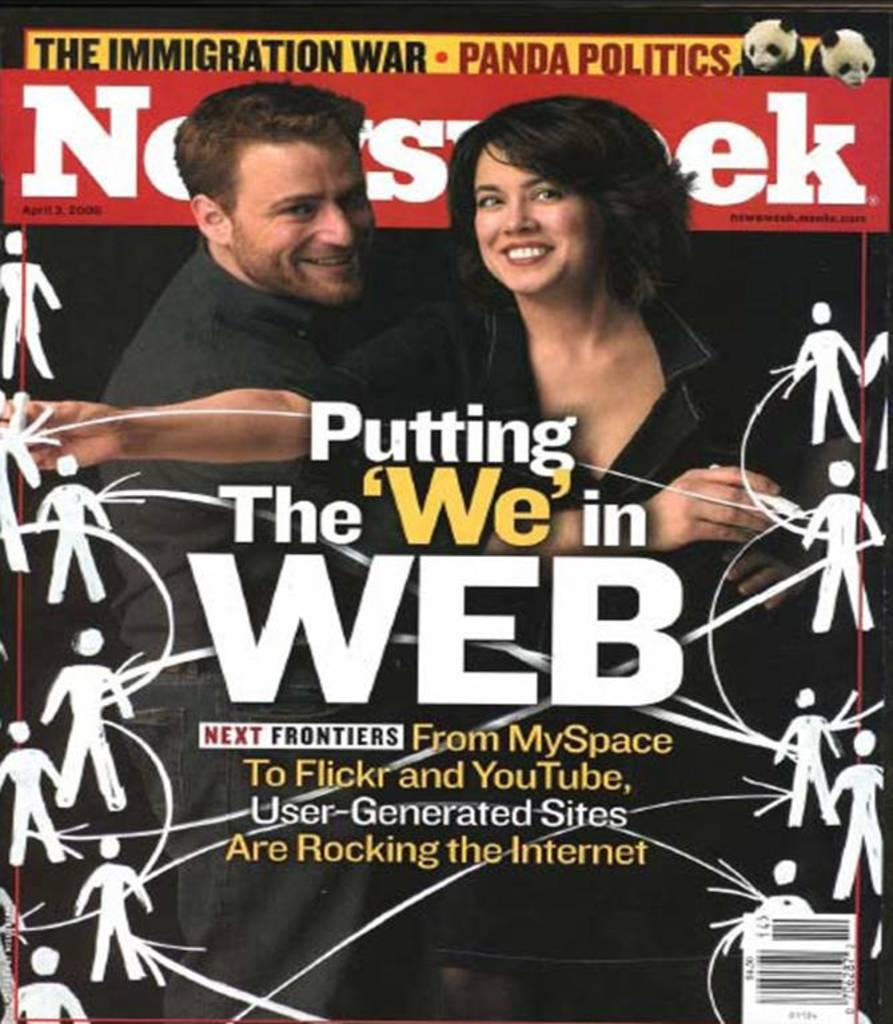<image>
Render a clear and concise summary of the photo. An edition of Newsweek magazine featuring stories about user generated websites. 